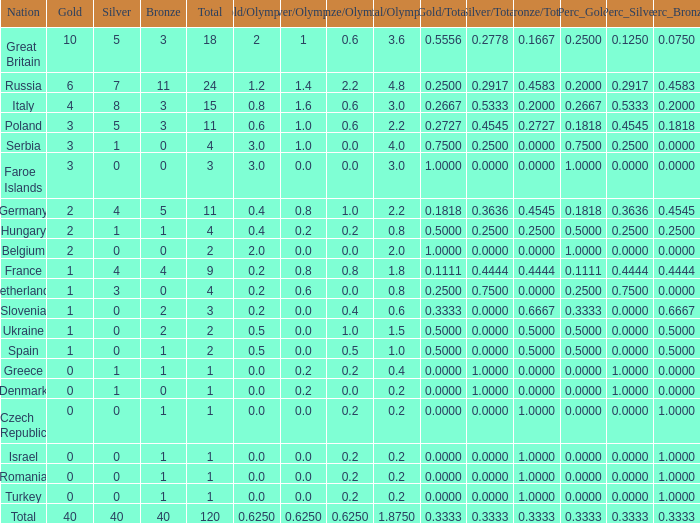What is Turkey's average Gold entry that also has a Bronze entry that is smaller than 2 and the Total is greater than 1? None. Could you help me parse every detail presented in this table? {'header': ['Nation', 'Gold', 'Silver', 'Bronze', 'Total', 'Gold/Olympiad', 'Silver/Olympiad', 'Bronze/Olympiad', 'Total/Olympiad', 'Gold/Total', 'Silver/Total', 'Bronze/Total', 'Perc_Gold', 'Perc_Silver', 'Perc_Bronze'], 'rows': [['Great Britain', '10', '5', '3', '18', '2', '1', '0.6', '3.6', '0.5556', '0.2778', '0.1667', '0.2500', '0.1250', '0.0750'], ['Russia', '6', '7', '11', '24', '1.2', '1.4', '2.2', '4.8', '0.2500', '0.2917', '0.4583', '0.2000', '0.2917', '0.4583'], ['Italy', '4', '8', '3', '15', '0.8', '1.6', '0.6', '3.0', '0.2667', '0.5333', '0.2000', '0.2667', '0.5333', '0.2000'], ['Poland', '3', '5', '3', '11', '0.6', '1.0', '0.6', '2.2', '0.2727', '0.4545', '0.2727', '0.1818', '0.4545', '0.1818'], ['Serbia', '3', '1', '0', '4', '3.0', '1.0', '0.0', '4.0', '0.7500', '0.2500', '0.0000', '0.7500', '0.2500', '0.0000'], ['Faroe Islands', '3', '0', '0', '3', '3.0', '0.0', '0.0', '3.0', '1.0000', '0.0000', '0.0000', '1.0000', '0.0000', '0.0000'], ['Germany', '2', '4', '5', '11', '0.4', '0.8', '1.0', '2.2', '0.1818', '0.3636', '0.4545', '0.1818', '0.3636', '0.4545'], ['Hungary', '2', '1', '1', '4', '0.4', '0.2', '0.2', '0.8', '0.5000', '0.2500', '0.2500', '0.5000', '0.2500', '0.2500'], ['Belgium', '2', '0', '0', '2', '2.0', '0.0', '0.0', '2.0', '1.0000', '0.0000', '0.0000', '1.0000', '0.0000', '0.0000'], ['France', '1', '4', '4', '9', '0.2', '0.8', '0.8', '1.8', '0.1111', '0.4444', '0.4444', '0.1111', '0.4444', '0.4444'], ['Netherlands', '1', '3', '0', '4', '0.2', '0.6', '0.0', '0.8', '0.2500', '0.7500', '0.0000', '0.2500', '0.7500', '0.0000'], ['Slovenia', '1', '0', '2', '3', '0.2', '0.0', '0.4', '0.6', '0.3333', '0.0000', '0.6667', '0.3333', '0.0000', '0.6667'], ['Ukraine', '1', '0', '2', '2', '0.5', '0.0', '1.0', '1.5', '0.5000', '0.0000', '0.5000', '0.5000', '0.0000', '0.5000'], ['Spain', '1', '0', '1', '2', '0.5', '0.0', '0.5', '1.0', '0.5000', '0.0000', '0.5000', '0.5000', '0.0000', '0.5000'], ['Greece', '0', '1', '1', '1', '0.0', '0.2', '0.2', '0.4', '0.0000', '1.0000', '0.0000', '0.0000', '1.0000', '0.0000'], ['Denmark', '0', '1', '0', '1', '0.0', '0.2', '0.0', '0.2', '0.0000', '1.0000', '0.0000', '0.0000', '1.0000', '0.0000'], ['Czech Republic', '0', '0', '1', '1', '0.0', '0.0', '0.2', '0.2', '0.0000', '0.0000', '1.0000', '0.0000', '0.0000', '1.0000'], ['Israel', '0', '0', '1', '1', '0.0', '0.0', '0.2', '0.2', '0.0000', '0.0000', '1.0000', '0.0000', '0.0000', '1.0000'], ['Romania', '0', '0', '1', '1', '0.0', '0.0', '0.2', '0.2', '0.0000', '0.0000', '1.0000', '0.0000', '0.0000', '1.0000'], ['Turkey', '0', '0', '1', '1', '0.0', '0.0', '0.2', '0.2', '0.0000', '0.0000', '1.0000', '0.0000', '0.0000', '1.0000'], ['Total', '40', '40', '40', '120', '0.6250', '0.6250', '0.6250', '1.8750', '0.3333', '0.3333', '0.3333', '0.3333', '0.3333', '0.3333']]} 